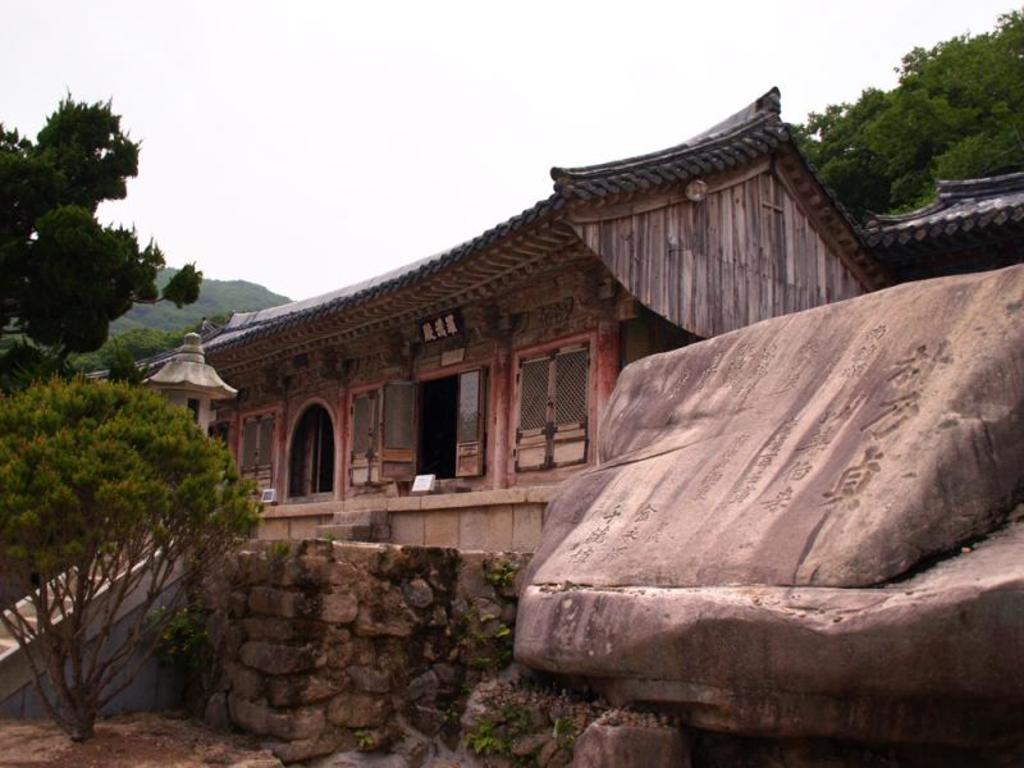What is the main object in the image? There is a stone in the image. What structure is located near the stone? There is a house beside the stone. What type of vegetation can be seen in the image? There are trees visible at the back side of the image. How many servants are standing beside the stone in the image? There are no servants present in the image. What type of cracker is placed on top of the stone in the image? There is no cracker present in the image. 